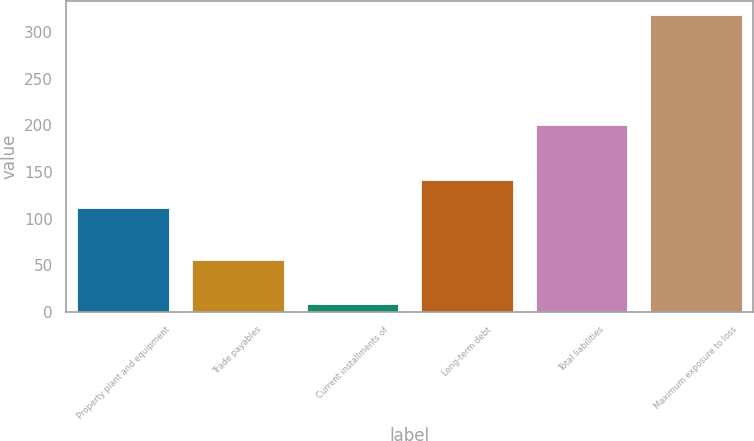Convert chart. <chart><loc_0><loc_0><loc_500><loc_500><bar_chart><fcel>Property plant and equipment<fcel>Trade payables<fcel>Current installments of<fcel>Long-term debt<fcel>Total liabilities<fcel>Maximum exposure to loss<nl><fcel>111<fcel>56<fcel>8<fcel>142<fcel>200<fcel>318<nl></chart> 